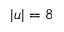Convert formula to latex. <formula><loc_0><loc_0><loc_500><loc_500>| u | = 8</formula> 